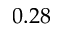Convert formula to latex. <formula><loc_0><loc_0><loc_500><loc_500>0 . 2 8</formula> 